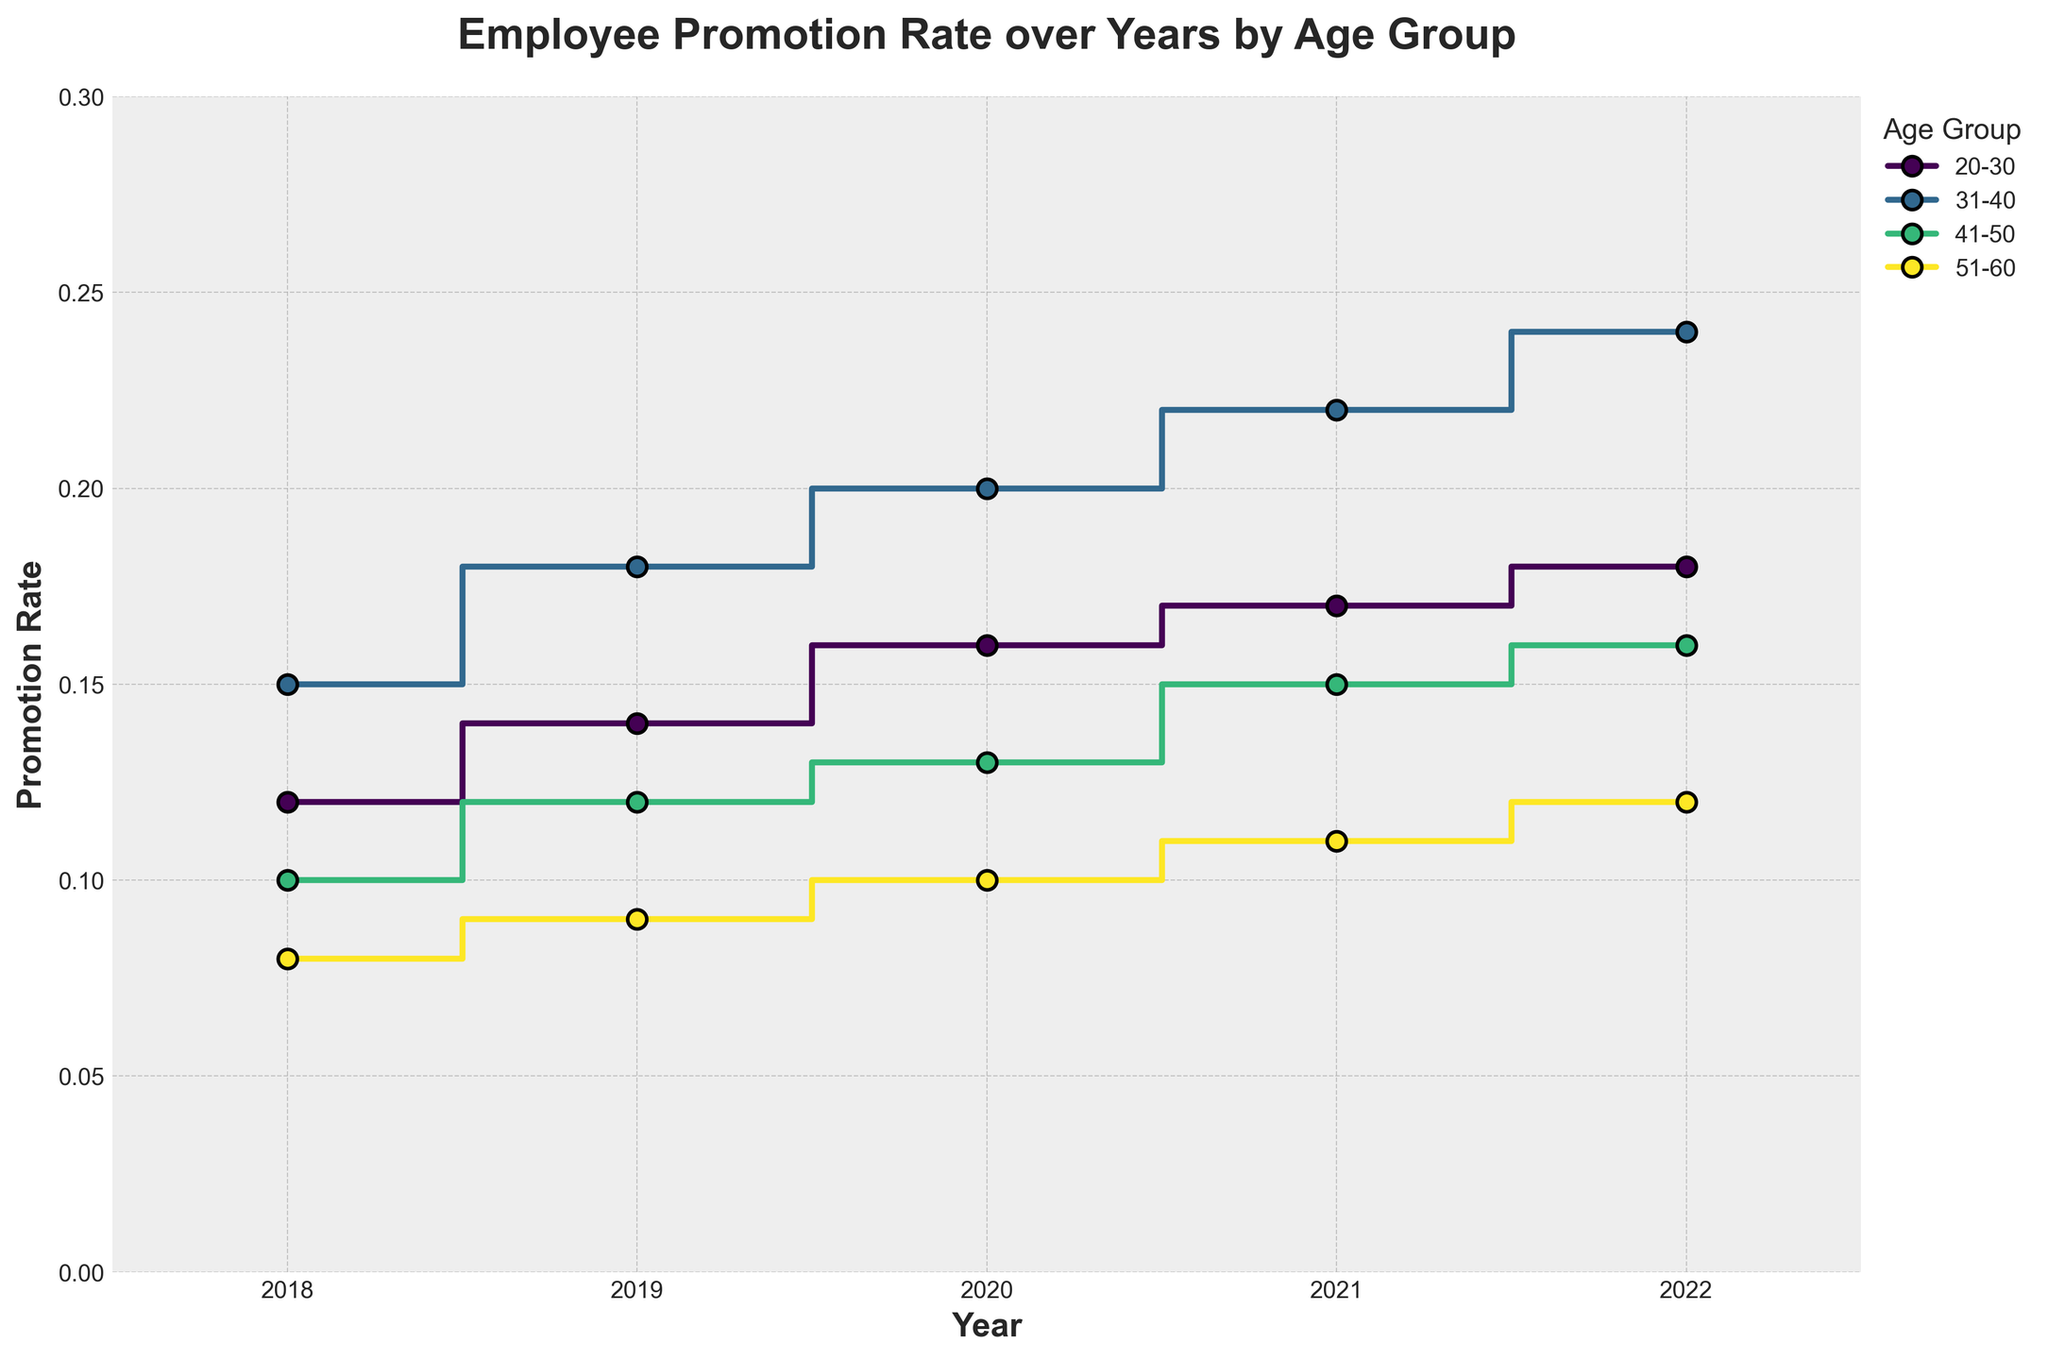What is the title of the plot? The title of the plot is usually positioned at the top of the figure. It reads: "Employee Promotion Rate over Years by Age Group".
Answer: Employee Promotion Rate over Years by Age Group How many years are represented in the plot? The x-axis shows each year as ticks from 2018 to 2022. Counting these ticks gives the total number of years represented.
Answer: 5 What color scheme is used to differentiate the age groups in the plot? The color scheme used is based on the Viridis colormap, which provides a gradient of colors to distinguish the different age groups.
Answer: Viridis colormap Which age group had the highest promotion rate in 2022? Looking at the steps for the year 2022, the age group with the highest vertical position corresponds to the group aged 31-40.
Answer: 31-40 What is the overall trend in promotion rates over the years for the age group 20-30? Observing the steps for the 20-30 age group from 2018 to 2022, the promotion rate increases each year.
Answer: Increasing trend In which year did the age group 51-60 see the lowest promotion rate? By checking the vertical levels of the steps for the 51-60 age group across the years, the lowest point is in the year 2018.
Answer: 2018 Comparing the promotion rates in 2020, which age group had a higher rate, 41-50 or 51-60? In 2020, the step representing the 41-50 age group is higher than the step for the 51-60 age group.
Answer: 41-50 What is the difference in promotion rates between the age groups 31-40 and 41-50 in 2019? For 2019, the promotion rate for 31-40 is 0.18 and for 41-50 is 0.12. The difference is 0.18 - 0.12.
Answer: 0.06 Which age group experienced the most significant increase in promotion rate from 2018 to 2022? Comparison of the promotion rates from 2018 to 2022 for all age groups shows that the age group 31-40 increased from 0.15 to 0.24, which is the most significant increase.
Answer: 31-40 How does the promotion rate for the age group 20-30 in 2021 compare to that in 2020? The promotion rate for the age group 20-30 in 2021 is 0.17 and in 2020 it is 0.16. Comparing these values shows that 2021 is slightly higher.
Answer: 2021 is higher 